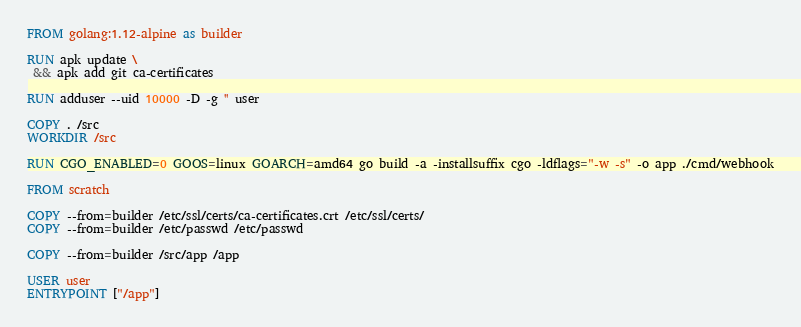Convert code to text. <code><loc_0><loc_0><loc_500><loc_500><_Dockerfile_>FROM golang:1.12-alpine as builder

RUN apk update \
 && apk add git ca-certificates

RUN adduser --uid 10000 -D -g '' user

COPY . /src
WORKDIR /src

RUN CGO_ENABLED=0 GOOS=linux GOARCH=amd64 go build -a -installsuffix cgo -ldflags="-w -s" -o app ./cmd/webhook

FROM scratch

COPY --from=builder /etc/ssl/certs/ca-certificates.crt /etc/ssl/certs/
COPY --from=builder /etc/passwd /etc/passwd

COPY --from=builder /src/app /app

USER user
ENTRYPOINT ["/app"]</code> 